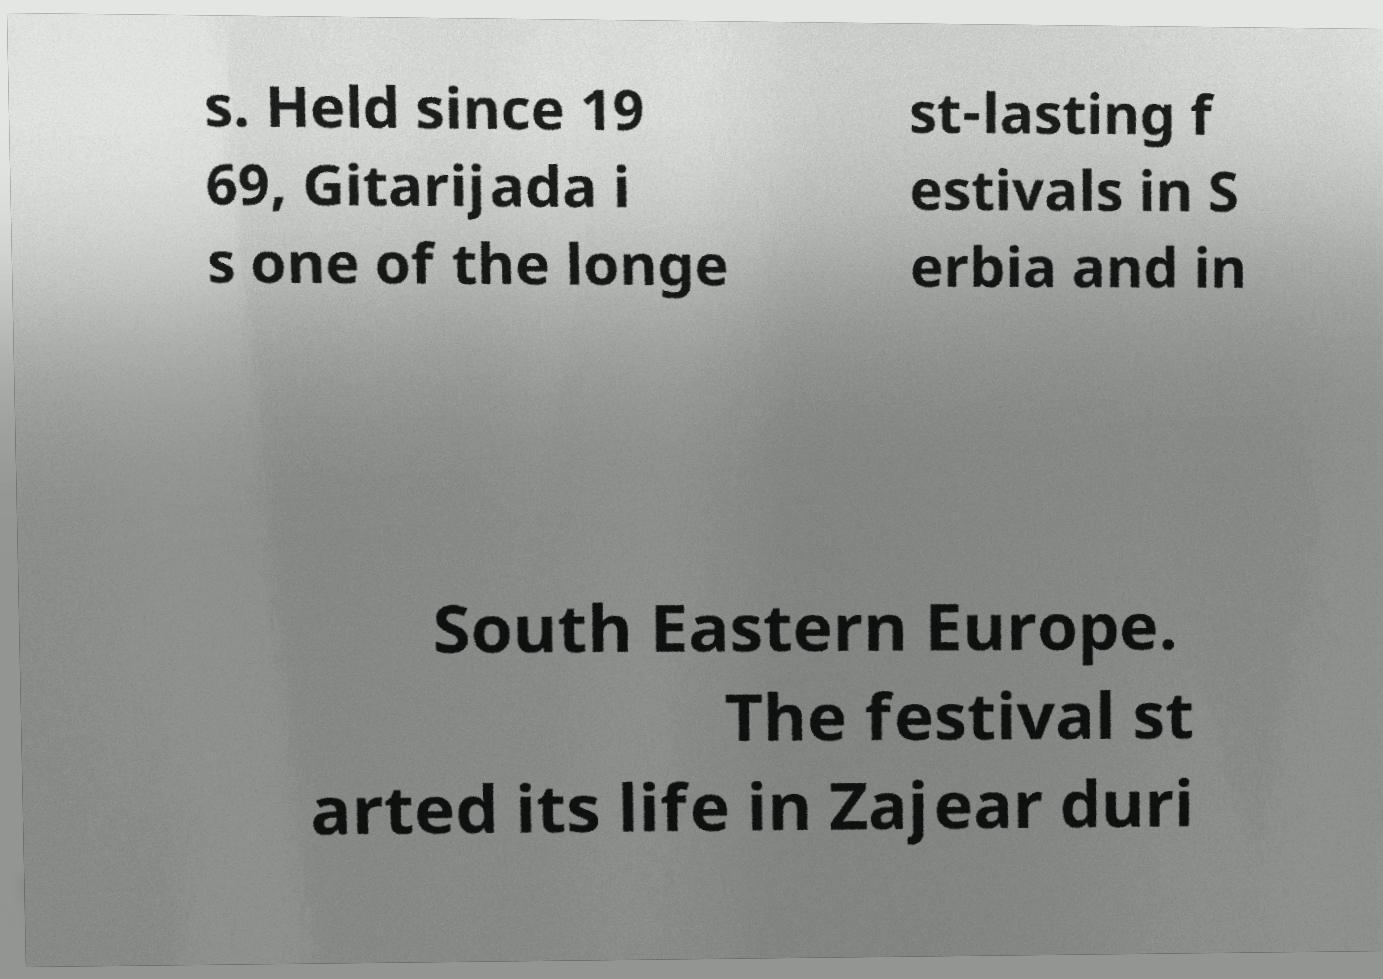Please read and relay the text visible in this image. What does it say? s. Held since 19 69, Gitarijada i s one of the longe st-lasting f estivals in S erbia and in South Eastern Europe. The festival st arted its life in Zajear duri 